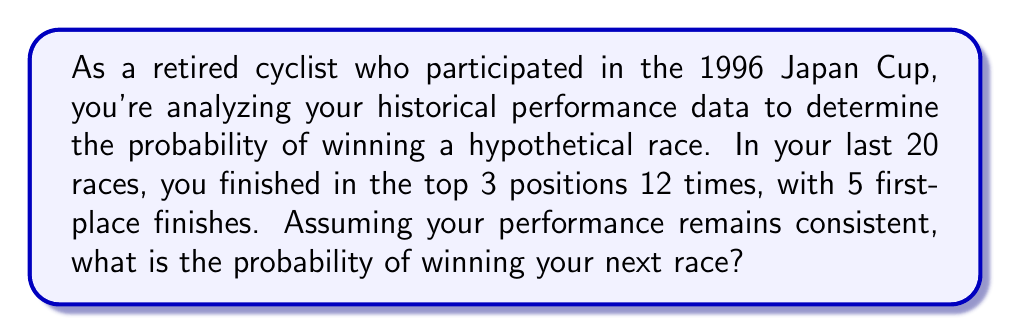Help me with this question. Let's approach this step-by-step:

1) First, we need to calculate the probability of winning based on the given historical data.

2) We're told that out of 20 races:
   - You finished in the top 3 positions 12 times
   - You had 5 first-place finishes

3) To calculate the probability of winning, we use the formula:

   $$P(\text{winning}) = \frac{\text{Number of favorable outcomes}}{\text{Total number of outcomes}}$$

4) In this case:
   - Number of favorable outcomes (wins) = 5
   - Total number of outcomes (races) = 20

5) Plugging these numbers into our formula:

   $$P(\text{winning}) = \frac{5}{20} = \frac{1}{4} = 0.25$$

6) We can express this as a percentage:

   $$0.25 \times 100\% = 25\%$$

Therefore, assuming your performance remains consistent with your historical data, the probability of winning your next race is 0.25 or 25%.
Answer: $0.25$ or $25\%$ 